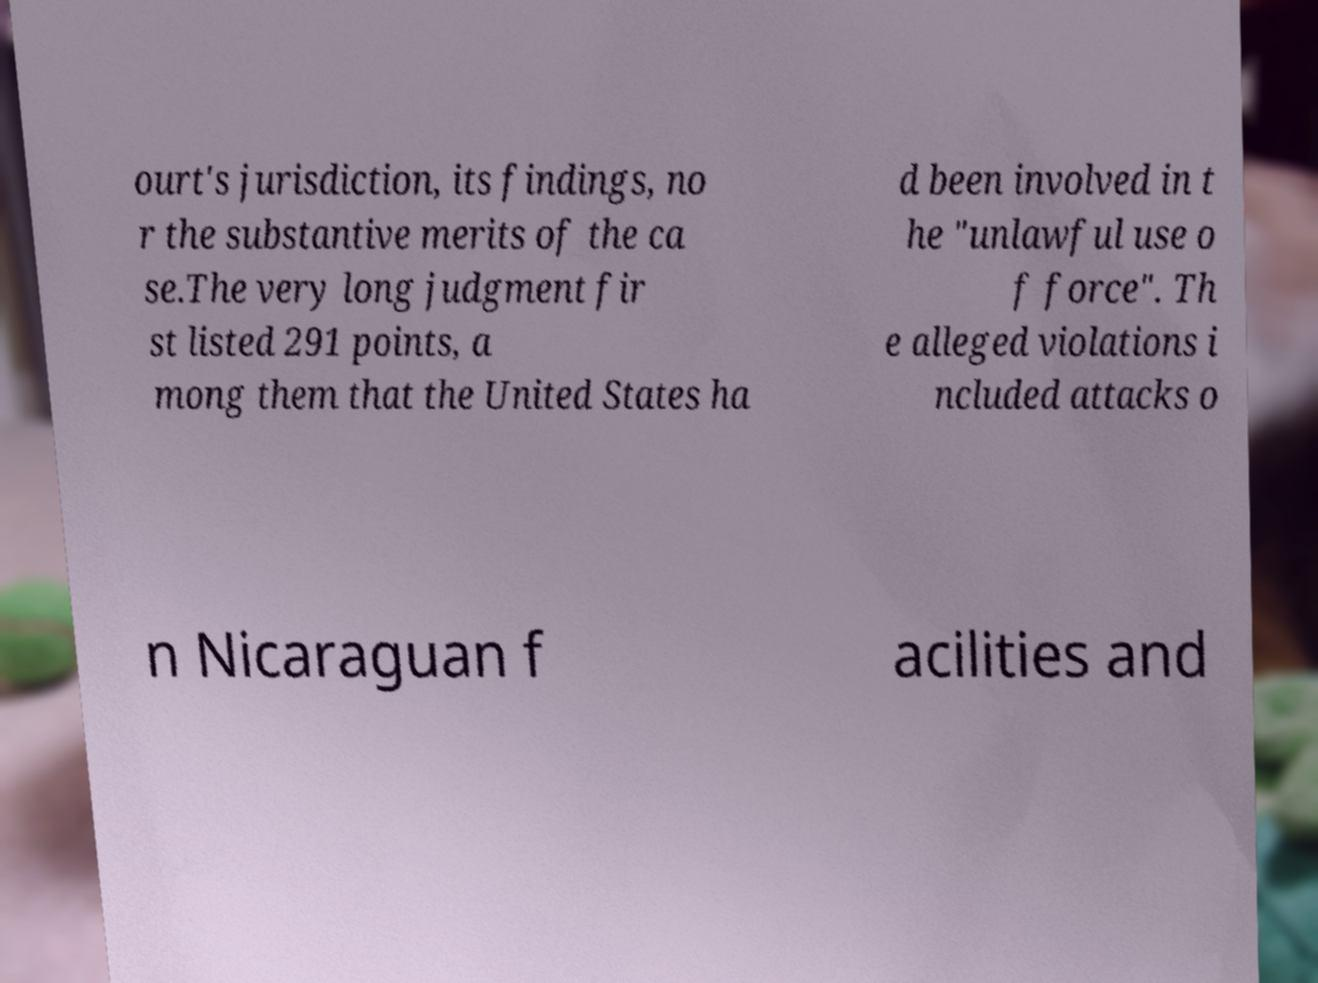There's text embedded in this image that I need extracted. Can you transcribe it verbatim? ourt's jurisdiction, its findings, no r the substantive merits of the ca se.The very long judgment fir st listed 291 points, a mong them that the United States ha d been involved in t he "unlawful use o f force". Th e alleged violations i ncluded attacks o n Nicaraguan f acilities and 